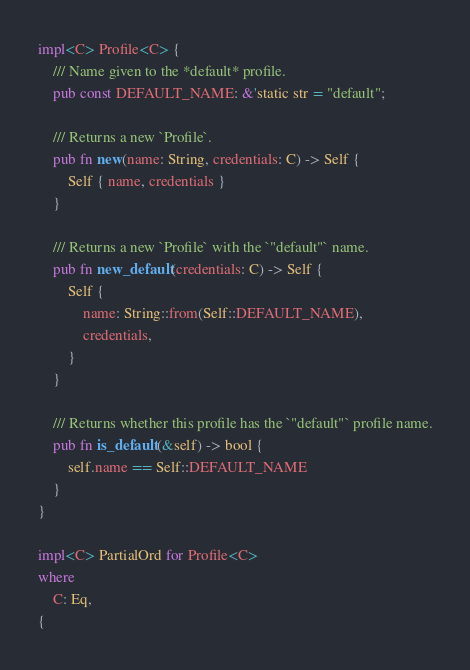Convert code to text. <code><loc_0><loc_0><loc_500><loc_500><_Rust_>
impl<C> Profile<C> {
    /// Name given to the *default* profile.
    pub const DEFAULT_NAME: &'static str = "default";

    /// Returns a new `Profile`.
    pub fn new(name: String, credentials: C) -> Self {
        Self { name, credentials }
    }

    /// Returns a new `Profile` with the `"default"` name.
    pub fn new_default(credentials: C) -> Self {
        Self {
            name: String::from(Self::DEFAULT_NAME),
            credentials,
        }
    }

    /// Returns whether this profile has the `"default"` profile name.
    pub fn is_default(&self) -> bool {
        self.name == Self::DEFAULT_NAME
    }
}

impl<C> PartialOrd for Profile<C>
where
    C: Eq,
{</code> 